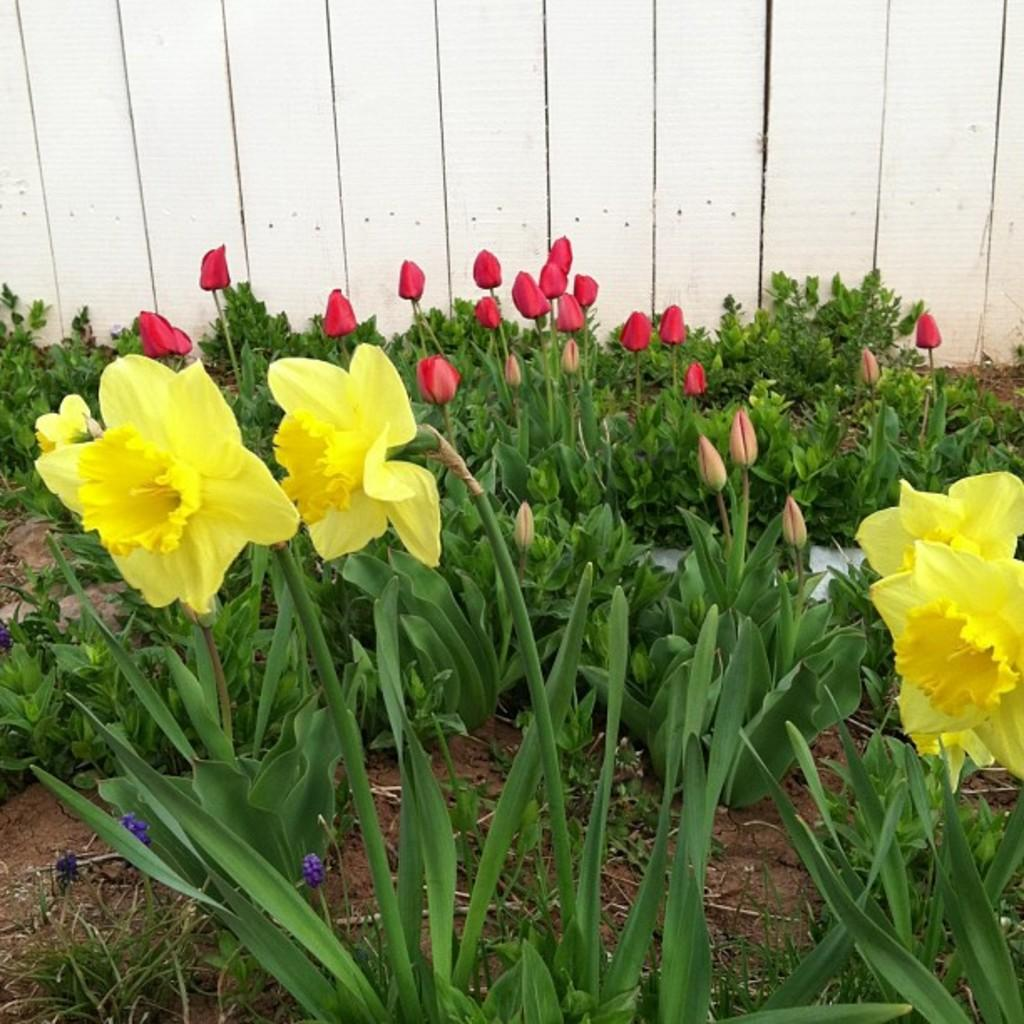What type of living organisms are present in the image? There are flowers in the image. What are the flowers growing on? The flowers are on plants. What colors can be seen in the flowers? The flowers are in yellow and red colors. What can be seen in the background of the image? There is a wooden wall in the background of the image. How many letters are visible on the quilt in the image? There is no quilt present in the image, and therefore no letters can be seen on it. 